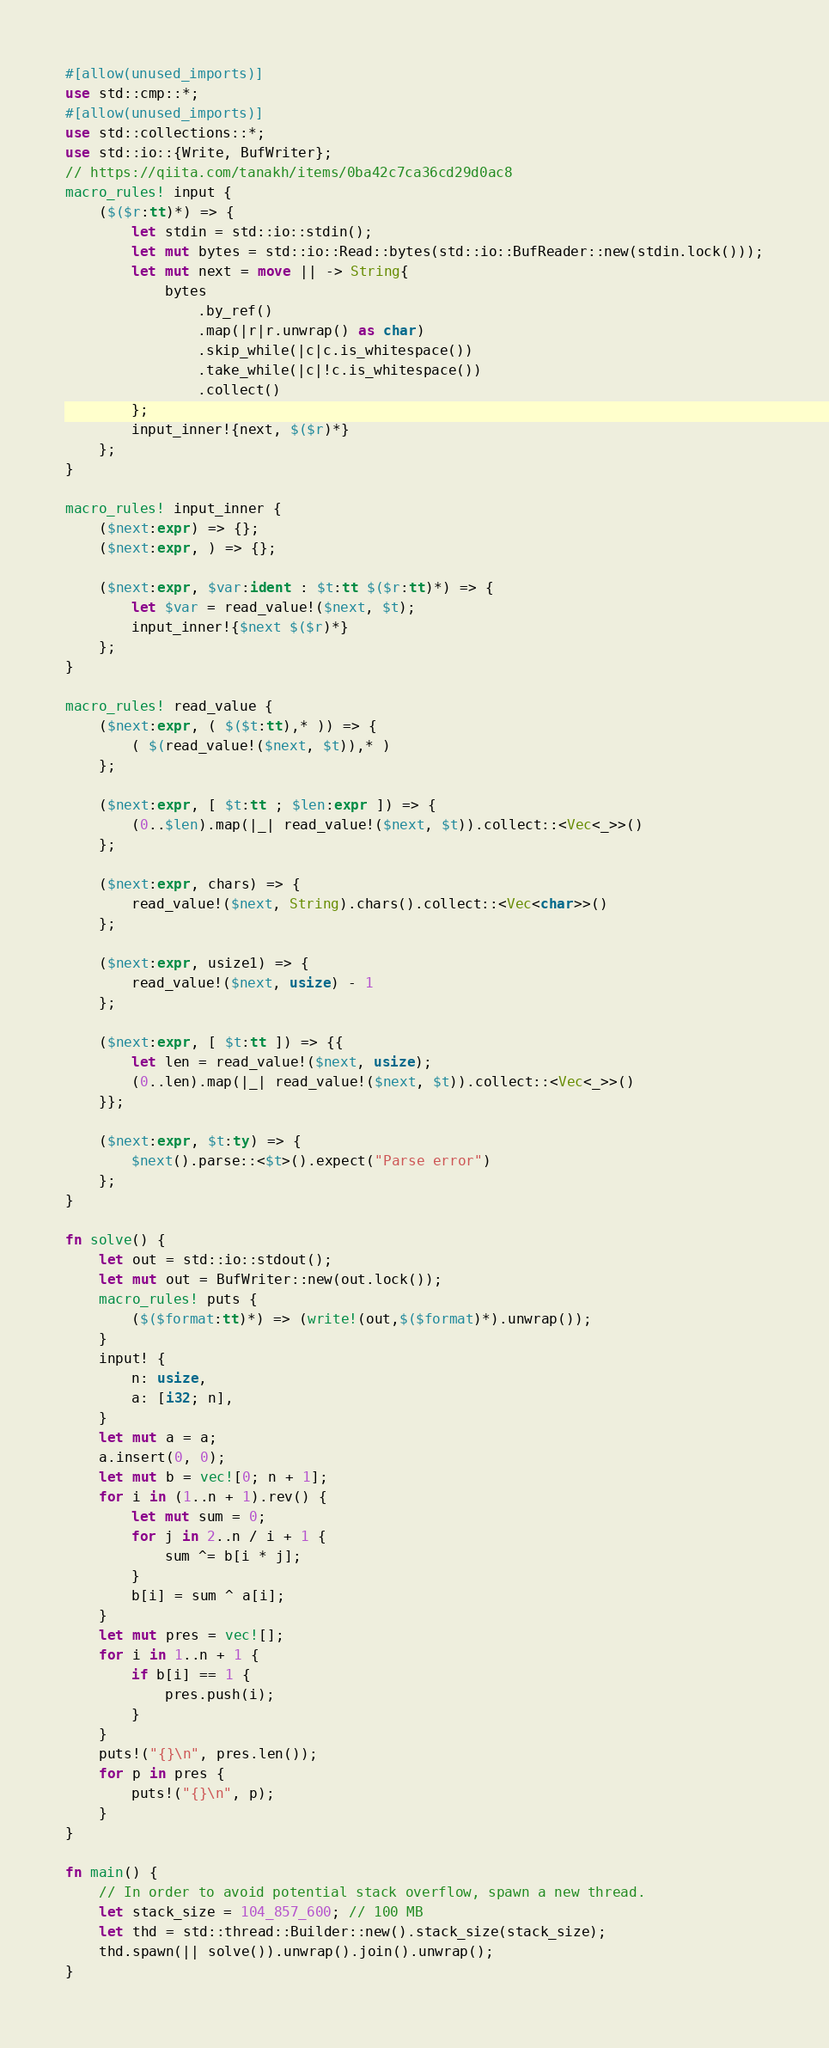Convert code to text. <code><loc_0><loc_0><loc_500><loc_500><_Rust_>#[allow(unused_imports)]
use std::cmp::*;
#[allow(unused_imports)]
use std::collections::*;
use std::io::{Write, BufWriter};
// https://qiita.com/tanakh/items/0ba42c7ca36cd29d0ac8
macro_rules! input {
    ($($r:tt)*) => {
        let stdin = std::io::stdin();
        let mut bytes = std::io::Read::bytes(std::io::BufReader::new(stdin.lock()));
        let mut next = move || -> String{
            bytes
                .by_ref()
                .map(|r|r.unwrap() as char)
                .skip_while(|c|c.is_whitespace())
                .take_while(|c|!c.is_whitespace())
                .collect()
        };
        input_inner!{next, $($r)*}
    };
}

macro_rules! input_inner {
    ($next:expr) => {};
    ($next:expr, ) => {};

    ($next:expr, $var:ident : $t:tt $($r:tt)*) => {
        let $var = read_value!($next, $t);
        input_inner!{$next $($r)*}
    };
}

macro_rules! read_value {
    ($next:expr, ( $($t:tt),* )) => {
        ( $(read_value!($next, $t)),* )
    };

    ($next:expr, [ $t:tt ; $len:expr ]) => {
        (0..$len).map(|_| read_value!($next, $t)).collect::<Vec<_>>()
    };

    ($next:expr, chars) => {
        read_value!($next, String).chars().collect::<Vec<char>>()
    };

    ($next:expr, usize1) => {
        read_value!($next, usize) - 1
    };

    ($next:expr, [ $t:tt ]) => {{
        let len = read_value!($next, usize);
        (0..len).map(|_| read_value!($next, $t)).collect::<Vec<_>>()
    }};

    ($next:expr, $t:ty) => {
        $next().parse::<$t>().expect("Parse error")
    };
}

fn solve() {
    let out = std::io::stdout();
    let mut out = BufWriter::new(out.lock());
    macro_rules! puts {
        ($($format:tt)*) => (write!(out,$($format)*).unwrap());
    }
    input! {
        n: usize,
        a: [i32; n],
    }
    let mut a = a;
    a.insert(0, 0);
    let mut b = vec![0; n + 1];
    for i in (1..n + 1).rev() {
        let mut sum = 0;
        for j in 2..n / i + 1 {
            sum ^= b[i * j];
        }
        b[i] = sum ^ a[i];
    }
    let mut pres = vec![];
    for i in 1..n + 1 {
        if b[i] == 1 {
            pres.push(i);
        }
    }
    puts!("{}\n", pres.len());
    for p in pres {
        puts!("{}\n", p);
    }
}

fn main() {
    // In order to avoid potential stack overflow, spawn a new thread.
    let stack_size = 104_857_600; // 100 MB
    let thd = std::thread::Builder::new().stack_size(stack_size);
    thd.spawn(|| solve()).unwrap().join().unwrap();
}
</code> 